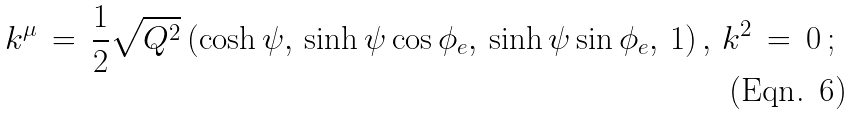Convert formula to latex. <formula><loc_0><loc_0><loc_500><loc_500>k ^ { \mu } \, = \, \frac { 1 } { 2 } \sqrt { Q ^ { 2 } } \, ( \cosh \psi , \, \sinh \psi \cos \phi _ { e } , \, \sinh \psi \sin \phi _ { e } , \, 1 ) \, , \, k ^ { 2 } \, = \, 0 \, ;</formula> 